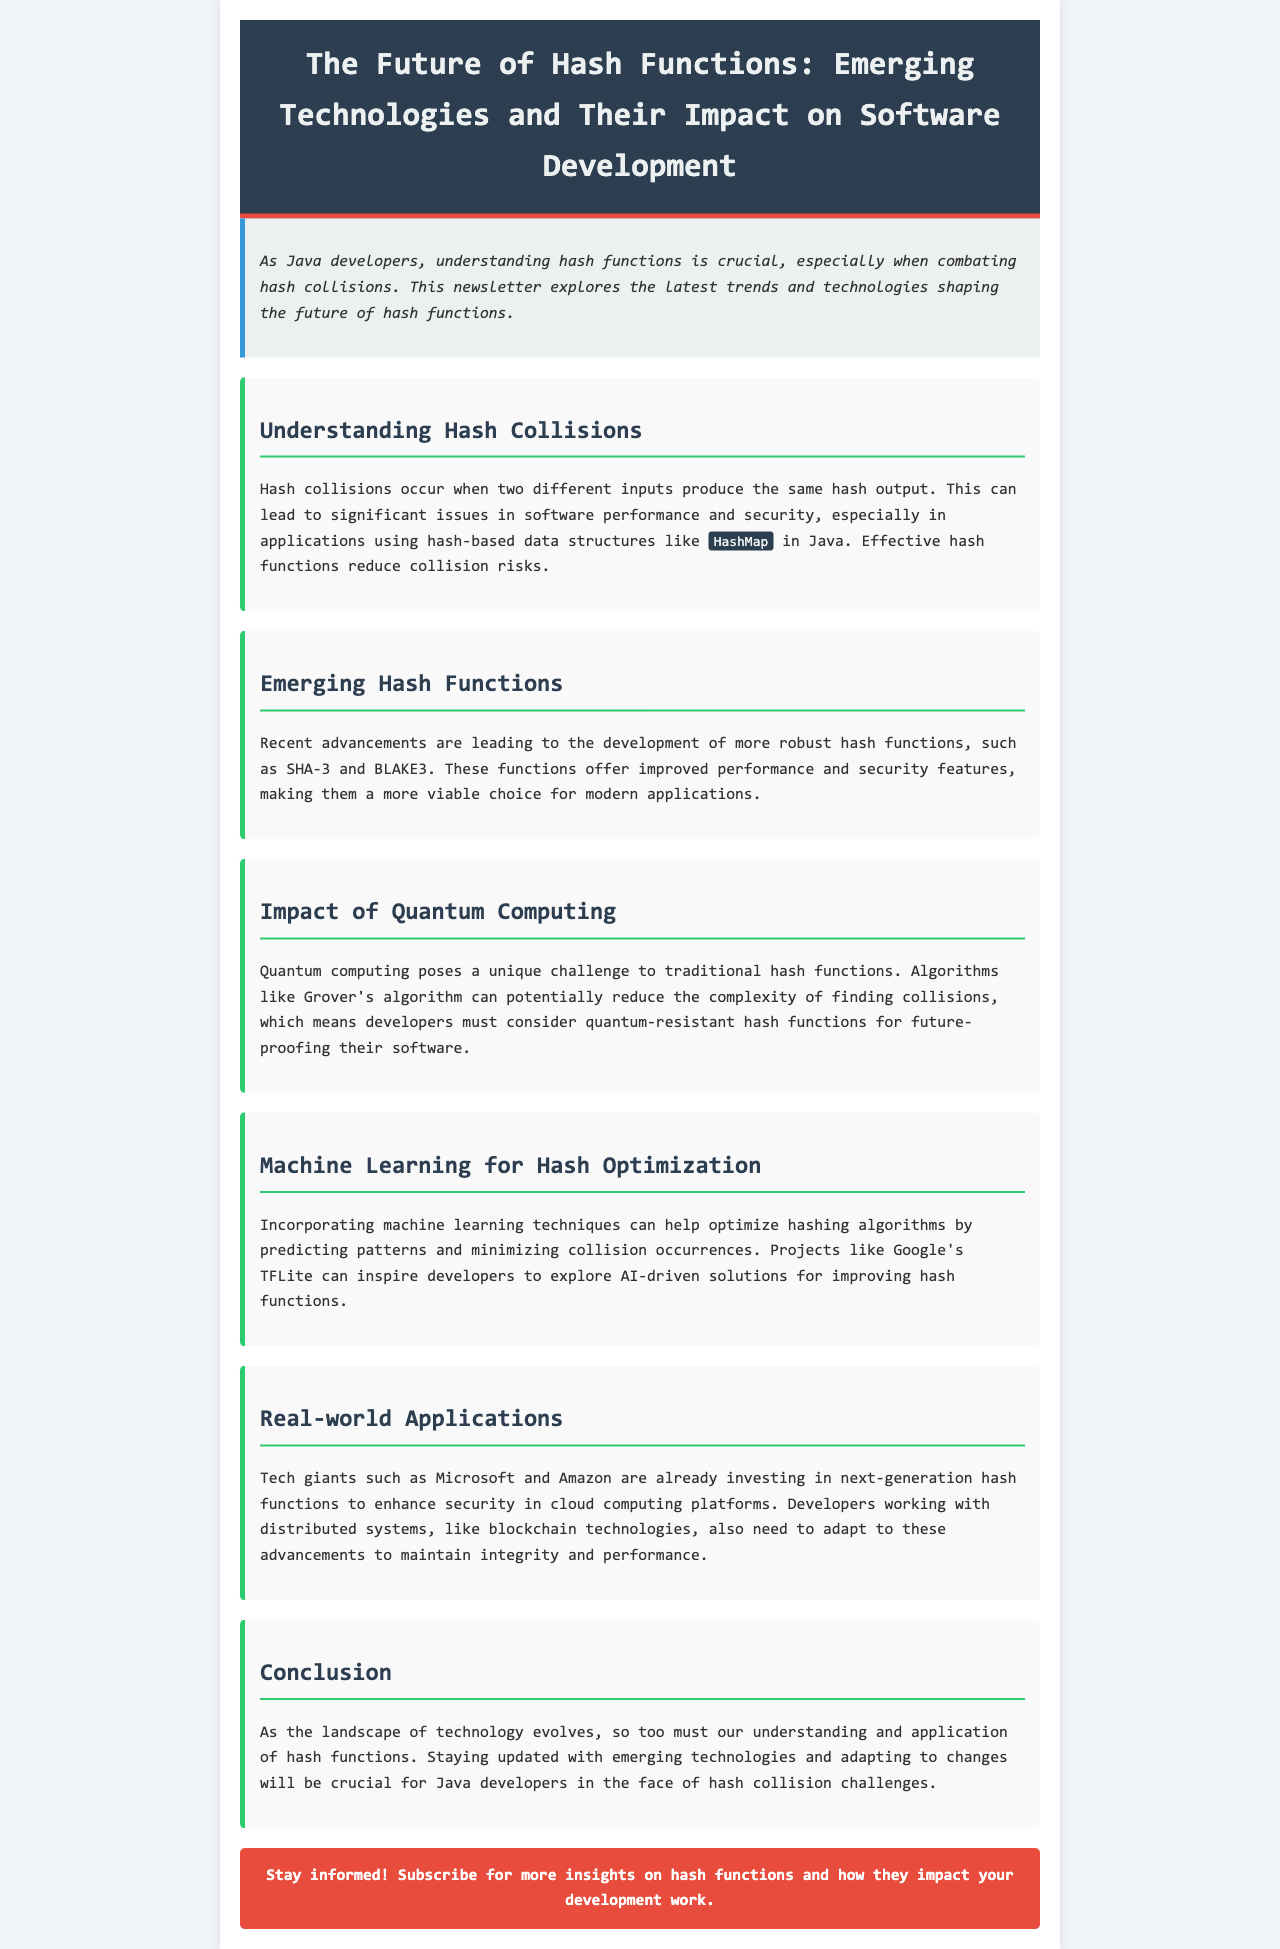What is the title of the newsletter? The title is prominently displayed in the header section of the document.
Answer: The Future of Hash Functions: Emerging Technologies and Their Impact on Software Development What are two emerging hash functions mentioned? The document lists advancements in hash functions along with their names.
Answer: SHA-3 and BLAKE3 What is a key challenge posed by quantum computing? The document highlights how quantum computing affects traditional hash functions in relation to collision finding.
Answer: Finding collisions Which major tech companies are mentioned in relation to hash function advancements? The document identifies companies that are investing in next-generation hash functions.
Answer: Microsoft and Amazon How can machine learning contribute to hash function optimization? The document describes the potential role of machine learning in minimizing collision occurrences.
Answer: Predicting patterns What is the call to action provided at the end of the newsletter? The document includes a section encouraging user engagement and subscription.
Answer: Subscribe for more insights on hash functions What issue do hash collisions create in Java applications? The document outlines the consequences of hash collisions specifically in a popular Java data structure.
Answer: Performance and security What is one usage area mentioned for advanced hash functions? The document indicates fields where adopting new hash functions is crucial for developers.
Answer: Cloud computing platforms 